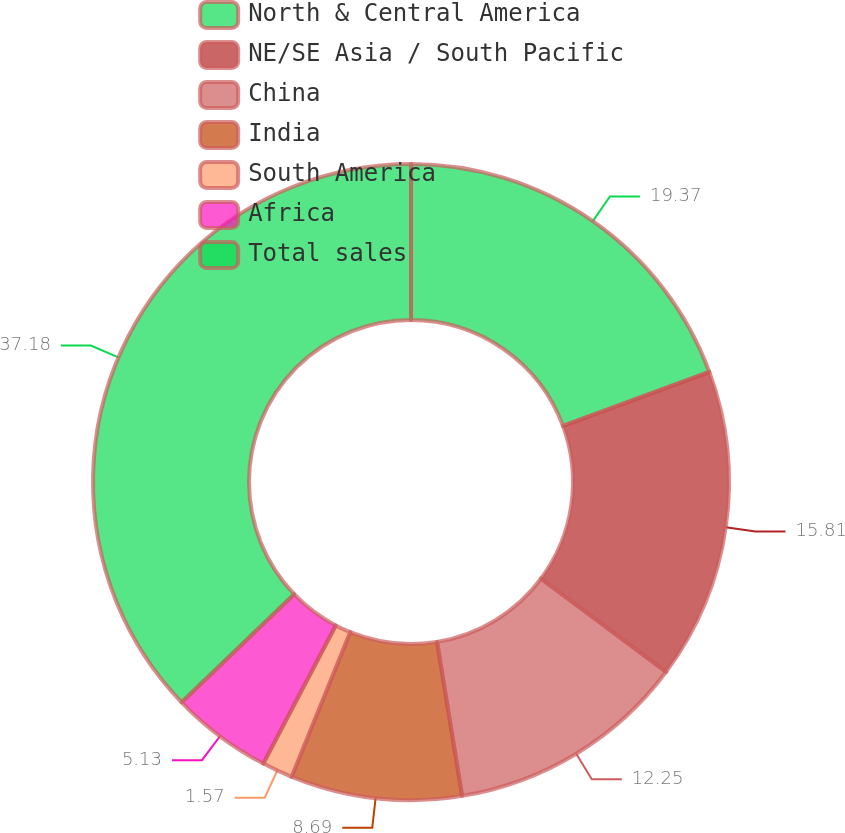<chart> <loc_0><loc_0><loc_500><loc_500><pie_chart><fcel>North & Central America<fcel>NE/SE Asia / South Pacific<fcel>China<fcel>India<fcel>South America<fcel>Africa<fcel>Total sales<nl><fcel>19.37%<fcel>15.81%<fcel>12.25%<fcel>8.69%<fcel>1.57%<fcel>5.13%<fcel>37.18%<nl></chart> 